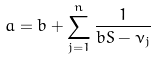<formula> <loc_0><loc_0><loc_500><loc_500>a = b + \sum _ { j = 1 } ^ { n } \frac { 1 } { b S - \nu _ { j } }</formula> 